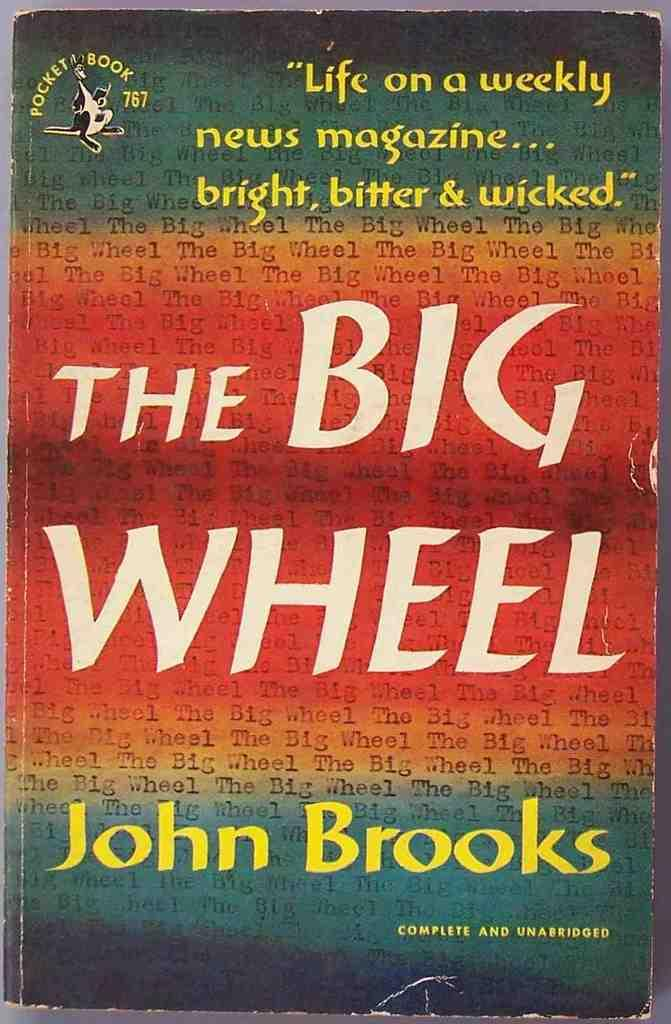<image>
Summarize the visual content of the image. A tattered looking book jacket for The Big Wheel by John Brooks. 